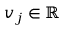<formula> <loc_0><loc_0><loc_500><loc_500>v _ { j } \in \mathbb { R }</formula> 